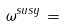<formula> <loc_0><loc_0><loc_500><loc_500>\omega ^ { s u s y } =</formula> 